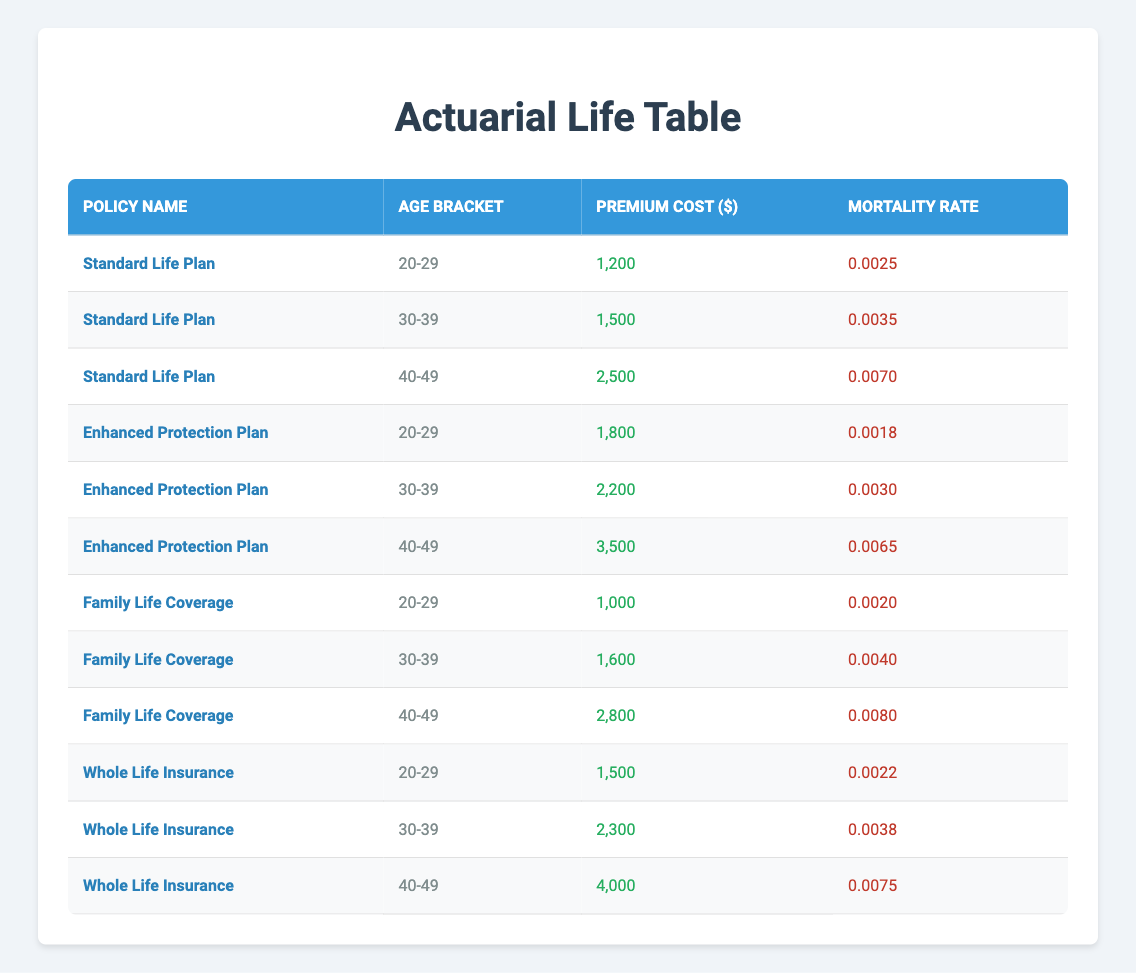What is the premium cost for the Enhanced Protection Plan for ages 30-39? The table indicates that the Enhanced Protection Plan has a premium cost of $2,200 for the age bracket of 30-39. This is directly referenced from the respective row in the table.
Answer: 2,200 Which policy has the highest premium cost for the age bracket 40-49? According to the table, the Whole Life Insurance policy has the highest premium cost of $4,000 for the age bracket of 40-49. This can be verified by comparing the premium costs of all policies for that age group.
Answer: 4,000 What is the difference in mortality rates between the Standard Life Plan and Family Life Coverage for ages 40-49? The mortality rate for the Standard Life Plan is 0.0070, and for the Family Life Coverage, it is 0.0080. The difference is calculated as 0.0080 - 0.0070 = 0.0010. Thus, the mortality rate for Family Life Coverage is higher by that amount.
Answer: 0.0010 Is the mortality rate for the Enhanced Protection Plan for ages 20-29 lower than that for the Standard Life Plan for the same age bracket? The mortality rate for the Enhanced Protection Plan for ages 20-29 is 0.0018, whereas the Standard Life Plan has a mortality rate of 0.0025. Since 0.0018 is less than 0.0025, the statement is true.
Answer: Yes What is the average premium cost for the policies listed for ages 30-39? The premium costs for ages 30-39 are $1,500 (Standard Life Plan), $2,200 (Enhanced Protection Plan), $1,600 (Family Life Coverage), and $2,300 (Whole Life Insurance). The total premium cost is 1,500 + 2,200 + 1,600 + 2,300 = 7,600. There are 4 policies, so the average is 7,600 / 4 = 1,900.
Answer: 1,900 Which policy has the lowest mortality rate for ages 20-29? For ages 20-29, the table lists the mortality rates as follows: Standard Life Plan: 0.0025, Enhanced Protection Plan: 0.0018, Family Life Coverage: 0.0020, Whole Life Insurance: 0.0022. The lowest rate among these is 0.0018 from the Enhanced Protection Plan.
Answer: Enhanced Protection Plan What is the total premium cost for all policies for ages 40-49? For ages 40-49, the premium costs are as follows: Standard Life Plan: $2,500, Enhanced Protection Plan: $3,500, Family Life Coverage: $2,800, and Whole Life Insurance: $4,000. To find the total, we add them: 2,500 + 3,500 + 2,800 + 4,000 = 13,800.
Answer: 13,800 Is the mortality rate for Whole Life Insurance for ages 30-39 greater than 0.0035? The mortality rate for Whole Life Insurance at age 30-39 is 0.0038, which is indeed greater than 0.0035. Therefore, the statement is true.
Answer: Yes What policy has the second-highest premium cost for ages 40-49? Upon inspection of the premium costs for ages 40-49, the values are: Standard Life Plan: $2,500, Enhanced Protection Plan: $3,500, Family Life Coverage: $2,800, and Whole Life Insurance: $4,000. When ranked, the second-highest premium cost is $3,500 for the Enhanced Protection Plan.
Answer: Enhanced Protection Plan 